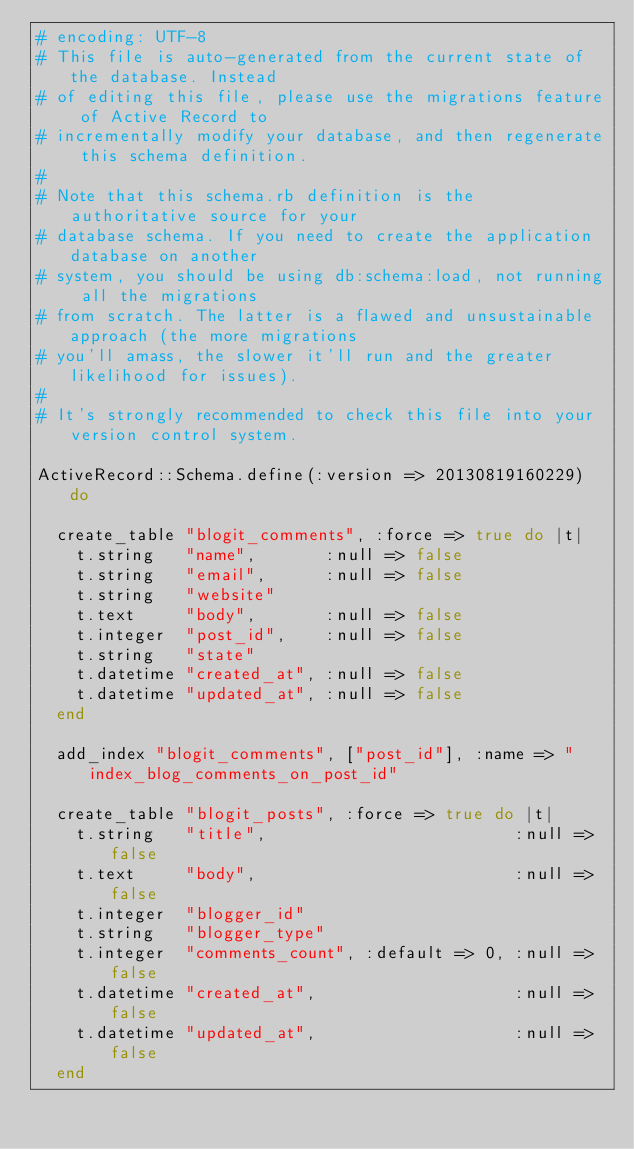Convert code to text. <code><loc_0><loc_0><loc_500><loc_500><_Ruby_># encoding: UTF-8
# This file is auto-generated from the current state of the database. Instead
# of editing this file, please use the migrations feature of Active Record to
# incrementally modify your database, and then regenerate this schema definition.
#
# Note that this schema.rb definition is the authoritative source for your
# database schema. If you need to create the application database on another
# system, you should be using db:schema:load, not running all the migrations
# from scratch. The latter is a flawed and unsustainable approach (the more migrations
# you'll amass, the slower it'll run and the greater likelihood for issues).
#
# It's strongly recommended to check this file into your version control system.

ActiveRecord::Schema.define(:version => 20130819160229) do

  create_table "blogit_comments", :force => true do |t|
    t.string   "name",       :null => false
    t.string   "email",      :null => false
    t.string   "website"
    t.text     "body",       :null => false
    t.integer  "post_id",    :null => false
    t.string   "state"
    t.datetime "created_at", :null => false
    t.datetime "updated_at", :null => false
  end

  add_index "blogit_comments", ["post_id"], :name => "index_blog_comments_on_post_id"

  create_table "blogit_posts", :force => true do |t|
    t.string   "title",                         :null => false
    t.text     "body",                          :null => false
    t.integer  "blogger_id"
    t.string   "blogger_type"
    t.integer  "comments_count", :default => 0, :null => false
    t.datetime "created_at",                    :null => false
    t.datetime "updated_at",                    :null => false
  end
</code> 